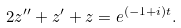<formula> <loc_0><loc_0><loc_500><loc_500>2 z ^ { \prime \prime } + z ^ { \prime } + z = e ^ { ( - 1 + i ) t } .</formula> 